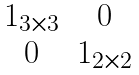<formula> <loc_0><loc_0><loc_500><loc_500>\begin{matrix} 1 _ { 3 \times 3 } & 0 \\ 0 & 1 _ { 2 \times 2 } \end{matrix}</formula> 